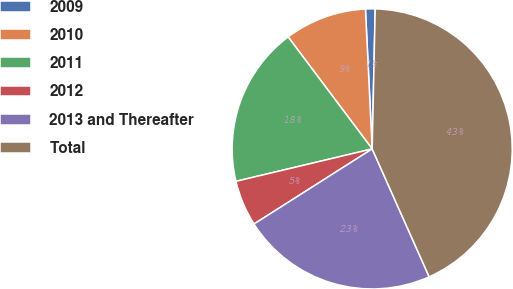Convert chart to OTSL. <chart><loc_0><loc_0><loc_500><loc_500><pie_chart><fcel>2009<fcel>2010<fcel>2011<fcel>2012<fcel>2013 and Thereafter<fcel>Total<nl><fcel>1.11%<fcel>9.48%<fcel>18.47%<fcel>5.29%<fcel>22.66%<fcel>42.98%<nl></chart> 